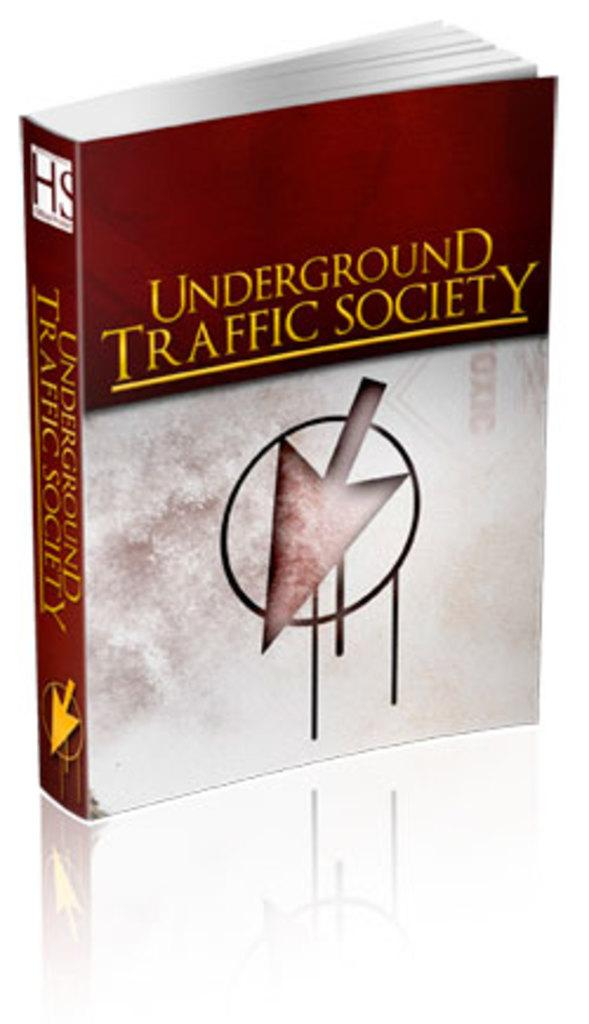<image>
Provide a brief description of the given image. A book called Underground Traffic Society has a big arrow on the front cover. 